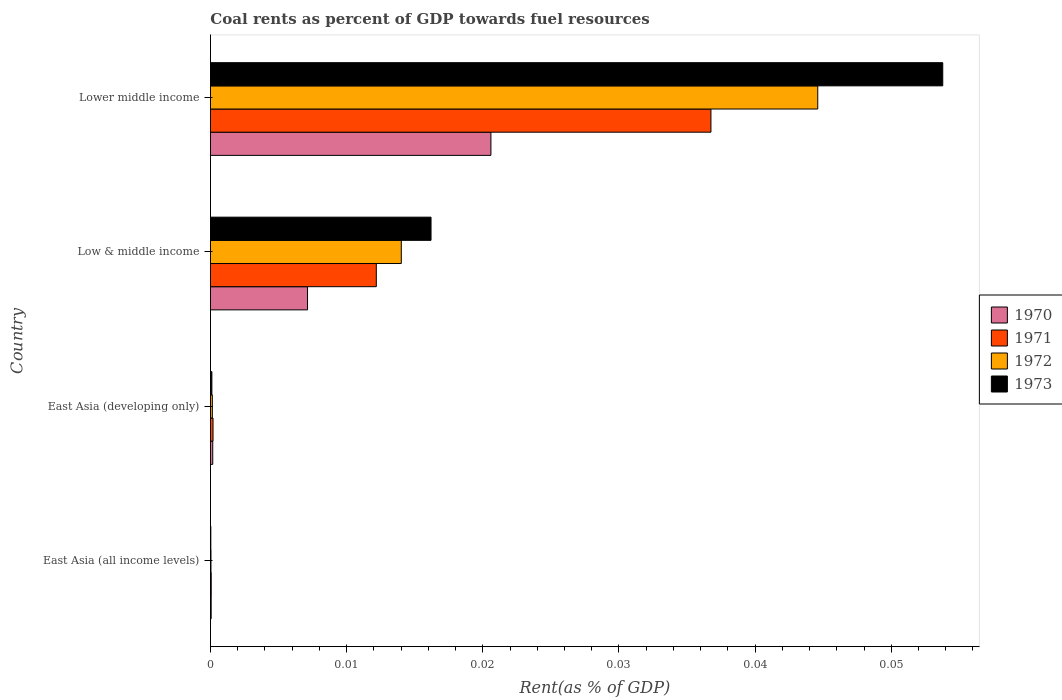How many different coloured bars are there?
Your response must be concise. 4. How many groups of bars are there?
Keep it short and to the point. 4. Are the number of bars on each tick of the Y-axis equal?
Offer a terse response. Yes. How many bars are there on the 3rd tick from the bottom?
Ensure brevity in your answer.  4. What is the label of the 2nd group of bars from the top?
Offer a very short reply. Low & middle income. What is the coal rent in 1972 in East Asia (all income levels)?
Provide a succinct answer. 3.67730514806032e-5. Across all countries, what is the maximum coal rent in 1970?
Provide a succinct answer. 0.02. Across all countries, what is the minimum coal rent in 1970?
Give a very brief answer. 5.1314079013758e-5. In which country was the coal rent in 1970 maximum?
Offer a very short reply. Lower middle income. In which country was the coal rent in 1970 minimum?
Provide a succinct answer. East Asia (all income levels). What is the total coal rent in 1973 in the graph?
Your response must be concise. 0.07. What is the difference between the coal rent in 1971 in East Asia (developing only) and that in Lower middle income?
Offer a terse response. -0.04. What is the difference between the coal rent in 1973 in Low & middle income and the coal rent in 1971 in East Asia (all income levels)?
Your answer should be very brief. 0.02. What is the average coal rent in 1970 per country?
Make the answer very short. 0.01. What is the difference between the coal rent in 1972 and coal rent in 1970 in East Asia (developing only)?
Provide a short and direct response. -2.9435221340923012e-5. What is the ratio of the coal rent in 1972 in East Asia (developing only) to that in Lower middle income?
Ensure brevity in your answer.  0. Is the coal rent in 1970 in East Asia (all income levels) less than that in East Asia (developing only)?
Ensure brevity in your answer.  Yes. Is the difference between the coal rent in 1972 in Low & middle income and Lower middle income greater than the difference between the coal rent in 1970 in Low & middle income and Lower middle income?
Your answer should be very brief. No. What is the difference between the highest and the second highest coal rent in 1972?
Your response must be concise. 0.03. What is the difference between the highest and the lowest coal rent in 1973?
Keep it short and to the point. 0.05. How many bars are there?
Provide a succinct answer. 16. Are all the bars in the graph horizontal?
Your response must be concise. Yes. Are the values on the major ticks of X-axis written in scientific E-notation?
Ensure brevity in your answer.  No. Does the graph contain any zero values?
Your answer should be compact. No. Does the graph contain grids?
Ensure brevity in your answer.  No. How many legend labels are there?
Ensure brevity in your answer.  4. How are the legend labels stacked?
Provide a succinct answer. Vertical. What is the title of the graph?
Give a very brief answer. Coal rents as percent of GDP towards fuel resources. What is the label or title of the X-axis?
Offer a very short reply. Rent(as % of GDP). What is the Rent(as % of GDP) of 1970 in East Asia (all income levels)?
Your answer should be compact. 5.1314079013758e-5. What is the Rent(as % of GDP) in 1971 in East Asia (all income levels)?
Provide a succinct answer. 5.470114168356261e-5. What is the Rent(as % of GDP) in 1972 in East Asia (all income levels)?
Your answer should be very brief. 3.67730514806032e-5. What is the Rent(as % of GDP) of 1973 in East Asia (all income levels)?
Your answer should be compact. 2.64171247686014e-5. What is the Rent(as % of GDP) in 1970 in East Asia (developing only)?
Give a very brief answer. 0. What is the Rent(as % of GDP) in 1971 in East Asia (developing only)?
Your answer should be very brief. 0. What is the Rent(as % of GDP) in 1972 in East Asia (developing only)?
Keep it short and to the point. 0. What is the Rent(as % of GDP) of 1973 in East Asia (developing only)?
Provide a succinct answer. 0. What is the Rent(as % of GDP) of 1970 in Low & middle income?
Your answer should be compact. 0.01. What is the Rent(as % of GDP) of 1971 in Low & middle income?
Your response must be concise. 0.01. What is the Rent(as % of GDP) in 1972 in Low & middle income?
Provide a short and direct response. 0.01. What is the Rent(as % of GDP) of 1973 in Low & middle income?
Offer a very short reply. 0.02. What is the Rent(as % of GDP) of 1970 in Lower middle income?
Offer a very short reply. 0.02. What is the Rent(as % of GDP) of 1971 in Lower middle income?
Ensure brevity in your answer.  0.04. What is the Rent(as % of GDP) of 1972 in Lower middle income?
Provide a succinct answer. 0.04. What is the Rent(as % of GDP) of 1973 in Lower middle income?
Your response must be concise. 0.05. Across all countries, what is the maximum Rent(as % of GDP) of 1970?
Keep it short and to the point. 0.02. Across all countries, what is the maximum Rent(as % of GDP) in 1971?
Offer a terse response. 0.04. Across all countries, what is the maximum Rent(as % of GDP) in 1972?
Offer a very short reply. 0.04. Across all countries, what is the maximum Rent(as % of GDP) in 1973?
Make the answer very short. 0.05. Across all countries, what is the minimum Rent(as % of GDP) in 1970?
Your response must be concise. 5.1314079013758e-5. Across all countries, what is the minimum Rent(as % of GDP) in 1971?
Make the answer very short. 5.470114168356261e-5. Across all countries, what is the minimum Rent(as % of GDP) of 1972?
Provide a short and direct response. 3.67730514806032e-5. Across all countries, what is the minimum Rent(as % of GDP) in 1973?
Your answer should be compact. 2.64171247686014e-5. What is the total Rent(as % of GDP) in 1970 in the graph?
Your answer should be compact. 0.03. What is the total Rent(as % of GDP) of 1971 in the graph?
Make the answer very short. 0.05. What is the total Rent(as % of GDP) of 1972 in the graph?
Offer a terse response. 0.06. What is the total Rent(as % of GDP) of 1973 in the graph?
Offer a very short reply. 0.07. What is the difference between the Rent(as % of GDP) of 1970 in East Asia (all income levels) and that in East Asia (developing only)?
Your answer should be compact. -0. What is the difference between the Rent(as % of GDP) in 1971 in East Asia (all income levels) and that in East Asia (developing only)?
Provide a succinct answer. -0. What is the difference between the Rent(as % of GDP) of 1972 in East Asia (all income levels) and that in East Asia (developing only)?
Make the answer very short. -0. What is the difference between the Rent(as % of GDP) of 1973 in East Asia (all income levels) and that in East Asia (developing only)?
Provide a short and direct response. -0. What is the difference between the Rent(as % of GDP) of 1970 in East Asia (all income levels) and that in Low & middle income?
Offer a very short reply. -0.01. What is the difference between the Rent(as % of GDP) in 1971 in East Asia (all income levels) and that in Low & middle income?
Your answer should be very brief. -0.01. What is the difference between the Rent(as % of GDP) in 1972 in East Asia (all income levels) and that in Low & middle income?
Keep it short and to the point. -0.01. What is the difference between the Rent(as % of GDP) of 1973 in East Asia (all income levels) and that in Low & middle income?
Your answer should be compact. -0.02. What is the difference between the Rent(as % of GDP) in 1970 in East Asia (all income levels) and that in Lower middle income?
Offer a very short reply. -0.02. What is the difference between the Rent(as % of GDP) of 1971 in East Asia (all income levels) and that in Lower middle income?
Keep it short and to the point. -0.04. What is the difference between the Rent(as % of GDP) of 1972 in East Asia (all income levels) and that in Lower middle income?
Provide a succinct answer. -0.04. What is the difference between the Rent(as % of GDP) in 1973 in East Asia (all income levels) and that in Lower middle income?
Make the answer very short. -0.05. What is the difference between the Rent(as % of GDP) in 1970 in East Asia (developing only) and that in Low & middle income?
Ensure brevity in your answer.  -0.01. What is the difference between the Rent(as % of GDP) of 1971 in East Asia (developing only) and that in Low & middle income?
Your answer should be compact. -0.01. What is the difference between the Rent(as % of GDP) of 1972 in East Asia (developing only) and that in Low & middle income?
Make the answer very short. -0.01. What is the difference between the Rent(as % of GDP) in 1973 in East Asia (developing only) and that in Low & middle income?
Provide a succinct answer. -0.02. What is the difference between the Rent(as % of GDP) in 1970 in East Asia (developing only) and that in Lower middle income?
Ensure brevity in your answer.  -0.02. What is the difference between the Rent(as % of GDP) of 1971 in East Asia (developing only) and that in Lower middle income?
Offer a very short reply. -0.04. What is the difference between the Rent(as % of GDP) of 1972 in East Asia (developing only) and that in Lower middle income?
Offer a very short reply. -0.04. What is the difference between the Rent(as % of GDP) in 1973 in East Asia (developing only) and that in Lower middle income?
Your answer should be very brief. -0.05. What is the difference between the Rent(as % of GDP) in 1970 in Low & middle income and that in Lower middle income?
Your answer should be compact. -0.01. What is the difference between the Rent(as % of GDP) in 1971 in Low & middle income and that in Lower middle income?
Provide a succinct answer. -0.02. What is the difference between the Rent(as % of GDP) of 1972 in Low & middle income and that in Lower middle income?
Your response must be concise. -0.03. What is the difference between the Rent(as % of GDP) of 1973 in Low & middle income and that in Lower middle income?
Offer a terse response. -0.04. What is the difference between the Rent(as % of GDP) in 1970 in East Asia (all income levels) and the Rent(as % of GDP) in 1971 in East Asia (developing only)?
Offer a very short reply. -0. What is the difference between the Rent(as % of GDP) in 1970 in East Asia (all income levels) and the Rent(as % of GDP) in 1972 in East Asia (developing only)?
Ensure brevity in your answer.  -0. What is the difference between the Rent(as % of GDP) in 1970 in East Asia (all income levels) and the Rent(as % of GDP) in 1973 in East Asia (developing only)?
Ensure brevity in your answer.  -0. What is the difference between the Rent(as % of GDP) in 1971 in East Asia (all income levels) and the Rent(as % of GDP) in 1972 in East Asia (developing only)?
Offer a terse response. -0. What is the difference between the Rent(as % of GDP) of 1972 in East Asia (all income levels) and the Rent(as % of GDP) of 1973 in East Asia (developing only)?
Offer a very short reply. -0. What is the difference between the Rent(as % of GDP) of 1970 in East Asia (all income levels) and the Rent(as % of GDP) of 1971 in Low & middle income?
Your response must be concise. -0.01. What is the difference between the Rent(as % of GDP) in 1970 in East Asia (all income levels) and the Rent(as % of GDP) in 1972 in Low & middle income?
Give a very brief answer. -0.01. What is the difference between the Rent(as % of GDP) in 1970 in East Asia (all income levels) and the Rent(as % of GDP) in 1973 in Low & middle income?
Make the answer very short. -0.02. What is the difference between the Rent(as % of GDP) of 1971 in East Asia (all income levels) and the Rent(as % of GDP) of 1972 in Low & middle income?
Your answer should be very brief. -0.01. What is the difference between the Rent(as % of GDP) in 1971 in East Asia (all income levels) and the Rent(as % of GDP) in 1973 in Low & middle income?
Offer a very short reply. -0.02. What is the difference between the Rent(as % of GDP) in 1972 in East Asia (all income levels) and the Rent(as % of GDP) in 1973 in Low & middle income?
Give a very brief answer. -0.02. What is the difference between the Rent(as % of GDP) of 1970 in East Asia (all income levels) and the Rent(as % of GDP) of 1971 in Lower middle income?
Make the answer very short. -0.04. What is the difference between the Rent(as % of GDP) of 1970 in East Asia (all income levels) and the Rent(as % of GDP) of 1972 in Lower middle income?
Your answer should be very brief. -0.04. What is the difference between the Rent(as % of GDP) in 1970 in East Asia (all income levels) and the Rent(as % of GDP) in 1973 in Lower middle income?
Your answer should be very brief. -0.05. What is the difference between the Rent(as % of GDP) in 1971 in East Asia (all income levels) and the Rent(as % of GDP) in 1972 in Lower middle income?
Give a very brief answer. -0.04. What is the difference between the Rent(as % of GDP) of 1971 in East Asia (all income levels) and the Rent(as % of GDP) of 1973 in Lower middle income?
Offer a very short reply. -0.05. What is the difference between the Rent(as % of GDP) of 1972 in East Asia (all income levels) and the Rent(as % of GDP) of 1973 in Lower middle income?
Your response must be concise. -0.05. What is the difference between the Rent(as % of GDP) in 1970 in East Asia (developing only) and the Rent(as % of GDP) in 1971 in Low & middle income?
Make the answer very short. -0.01. What is the difference between the Rent(as % of GDP) in 1970 in East Asia (developing only) and the Rent(as % of GDP) in 1972 in Low & middle income?
Provide a short and direct response. -0.01. What is the difference between the Rent(as % of GDP) of 1970 in East Asia (developing only) and the Rent(as % of GDP) of 1973 in Low & middle income?
Your response must be concise. -0.02. What is the difference between the Rent(as % of GDP) in 1971 in East Asia (developing only) and the Rent(as % of GDP) in 1972 in Low & middle income?
Offer a very short reply. -0.01. What is the difference between the Rent(as % of GDP) in 1971 in East Asia (developing only) and the Rent(as % of GDP) in 1973 in Low & middle income?
Ensure brevity in your answer.  -0.02. What is the difference between the Rent(as % of GDP) in 1972 in East Asia (developing only) and the Rent(as % of GDP) in 1973 in Low & middle income?
Keep it short and to the point. -0.02. What is the difference between the Rent(as % of GDP) in 1970 in East Asia (developing only) and the Rent(as % of GDP) in 1971 in Lower middle income?
Offer a very short reply. -0.04. What is the difference between the Rent(as % of GDP) in 1970 in East Asia (developing only) and the Rent(as % of GDP) in 1972 in Lower middle income?
Offer a terse response. -0.04. What is the difference between the Rent(as % of GDP) in 1970 in East Asia (developing only) and the Rent(as % of GDP) in 1973 in Lower middle income?
Your response must be concise. -0.05. What is the difference between the Rent(as % of GDP) of 1971 in East Asia (developing only) and the Rent(as % of GDP) of 1972 in Lower middle income?
Your answer should be compact. -0.04. What is the difference between the Rent(as % of GDP) of 1971 in East Asia (developing only) and the Rent(as % of GDP) of 1973 in Lower middle income?
Ensure brevity in your answer.  -0.05. What is the difference between the Rent(as % of GDP) in 1972 in East Asia (developing only) and the Rent(as % of GDP) in 1973 in Lower middle income?
Your response must be concise. -0.05. What is the difference between the Rent(as % of GDP) in 1970 in Low & middle income and the Rent(as % of GDP) in 1971 in Lower middle income?
Give a very brief answer. -0.03. What is the difference between the Rent(as % of GDP) of 1970 in Low & middle income and the Rent(as % of GDP) of 1972 in Lower middle income?
Provide a short and direct response. -0.04. What is the difference between the Rent(as % of GDP) of 1970 in Low & middle income and the Rent(as % of GDP) of 1973 in Lower middle income?
Provide a short and direct response. -0.05. What is the difference between the Rent(as % of GDP) in 1971 in Low & middle income and the Rent(as % of GDP) in 1972 in Lower middle income?
Ensure brevity in your answer.  -0.03. What is the difference between the Rent(as % of GDP) of 1971 in Low & middle income and the Rent(as % of GDP) of 1973 in Lower middle income?
Give a very brief answer. -0.04. What is the difference between the Rent(as % of GDP) of 1972 in Low & middle income and the Rent(as % of GDP) of 1973 in Lower middle income?
Offer a terse response. -0.04. What is the average Rent(as % of GDP) of 1970 per country?
Provide a short and direct response. 0.01. What is the average Rent(as % of GDP) of 1971 per country?
Provide a short and direct response. 0.01. What is the average Rent(as % of GDP) of 1972 per country?
Your answer should be very brief. 0.01. What is the average Rent(as % of GDP) in 1973 per country?
Your answer should be compact. 0.02. What is the difference between the Rent(as % of GDP) in 1970 and Rent(as % of GDP) in 1971 in East Asia (all income levels)?
Give a very brief answer. -0. What is the difference between the Rent(as % of GDP) in 1970 and Rent(as % of GDP) in 1973 in East Asia (all income levels)?
Provide a short and direct response. 0. What is the difference between the Rent(as % of GDP) of 1972 and Rent(as % of GDP) of 1973 in East Asia (all income levels)?
Your answer should be compact. 0. What is the difference between the Rent(as % of GDP) in 1970 and Rent(as % of GDP) in 1971 in East Asia (developing only)?
Provide a short and direct response. -0. What is the difference between the Rent(as % of GDP) of 1970 and Rent(as % of GDP) of 1971 in Low & middle income?
Provide a short and direct response. -0.01. What is the difference between the Rent(as % of GDP) of 1970 and Rent(as % of GDP) of 1972 in Low & middle income?
Your answer should be very brief. -0.01. What is the difference between the Rent(as % of GDP) in 1970 and Rent(as % of GDP) in 1973 in Low & middle income?
Give a very brief answer. -0.01. What is the difference between the Rent(as % of GDP) in 1971 and Rent(as % of GDP) in 1972 in Low & middle income?
Provide a short and direct response. -0. What is the difference between the Rent(as % of GDP) of 1971 and Rent(as % of GDP) of 1973 in Low & middle income?
Make the answer very short. -0. What is the difference between the Rent(as % of GDP) in 1972 and Rent(as % of GDP) in 1973 in Low & middle income?
Your response must be concise. -0. What is the difference between the Rent(as % of GDP) of 1970 and Rent(as % of GDP) of 1971 in Lower middle income?
Make the answer very short. -0.02. What is the difference between the Rent(as % of GDP) in 1970 and Rent(as % of GDP) in 1972 in Lower middle income?
Your answer should be very brief. -0.02. What is the difference between the Rent(as % of GDP) in 1970 and Rent(as % of GDP) in 1973 in Lower middle income?
Your answer should be very brief. -0.03. What is the difference between the Rent(as % of GDP) of 1971 and Rent(as % of GDP) of 1972 in Lower middle income?
Offer a very short reply. -0.01. What is the difference between the Rent(as % of GDP) of 1971 and Rent(as % of GDP) of 1973 in Lower middle income?
Provide a succinct answer. -0.02. What is the difference between the Rent(as % of GDP) in 1972 and Rent(as % of GDP) in 1973 in Lower middle income?
Ensure brevity in your answer.  -0.01. What is the ratio of the Rent(as % of GDP) of 1970 in East Asia (all income levels) to that in East Asia (developing only)?
Your response must be concise. 0.31. What is the ratio of the Rent(as % of GDP) of 1971 in East Asia (all income levels) to that in East Asia (developing only)?
Give a very brief answer. 0.29. What is the ratio of the Rent(as % of GDP) in 1972 in East Asia (all income levels) to that in East Asia (developing only)?
Ensure brevity in your answer.  0.27. What is the ratio of the Rent(as % of GDP) in 1973 in East Asia (all income levels) to that in East Asia (developing only)?
Provide a succinct answer. 0.26. What is the ratio of the Rent(as % of GDP) in 1970 in East Asia (all income levels) to that in Low & middle income?
Give a very brief answer. 0.01. What is the ratio of the Rent(as % of GDP) in 1971 in East Asia (all income levels) to that in Low & middle income?
Your answer should be very brief. 0. What is the ratio of the Rent(as % of GDP) in 1972 in East Asia (all income levels) to that in Low & middle income?
Keep it short and to the point. 0. What is the ratio of the Rent(as % of GDP) in 1973 in East Asia (all income levels) to that in Low & middle income?
Provide a succinct answer. 0. What is the ratio of the Rent(as % of GDP) of 1970 in East Asia (all income levels) to that in Lower middle income?
Provide a succinct answer. 0. What is the ratio of the Rent(as % of GDP) in 1971 in East Asia (all income levels) to that in Lower middle income?
Offer a very short reply. 0. What is the ratio of the Rent(as % of GDP) of 1972 in East Asia (all income levels) to that in Lower middle income?
Keep it short and to the point. 0. What is the ratio of the Rent(as % of GDP) in 1970 in East Asia (developing only) to that in Low & middle income?
Your answer should be compact. 0.02. What is the ratio of the Rent(as % of GDP) of 1971 in East Asia (developing only) to that in Low & middle income?
Give a very brief answer. 0.02. What is the ratio of the Rent(as % of GDP) in 1972 in East Asia (developing only) to that in Low & middle income?
Offer a terse response. 0.01. What is the ratio of the Rent(as % of GDP) of 1973 in East Asia (developing only) to that in Low & middle income?
Ensure brevity in your answer.  0.01. What is the ratio of the Rent(as % of GDP) in 1970 in East Asia (developing only) to that in Lower middle income?
Keep it short and to the point. 0.01. What is the ratio of the Rent(as % of GDP) of 1971 in East Asia (developing only) to that in Lower middle income?
Ensure brevity in your answer.  0.01. What is the ratio of the Rent(as % of GDP) in 1972 in East Asia (developing only) to that in Lower middle income?
Offer a very short reply. 0. What is the ratio of the Rent(as % of GDP) of 1973 in East Asia (developing only) to that in Lower middle income?
Offer a terse response. 0. What is the ratio of the Rent(as % of GDP) in 1970 in Low & middle income to that in Lower middle income?
Keep it short and to the point. 0.35. What is the ratio of the Rent(as % of GDP) in 1971 in Low & middle income to that in Lower middle income?
Your answer should be compact. 0.33. What is the ratio of the Rent(as % of GDP) in 1972 in Low & middle income to that in Lower middle income?
Provide a succinct answer. 0.31. What is the ratio of the Rent(as % of GDP) of 1973 in Low & middle income to that in Lower middle income?
Keep it short and to the point. 0.3. What is the difference between the highest and the second highest Rent(as % of GDP) in 1970?
Offer a very short reply. 0.01. What is the difference between the highest and the second highest Rent(as % of GDP) in 1971?
Provide a short and direct response. 0.02. What is the difference between the highest and the second highest Rent(as % of GDP) in 1972?
Your answer should be very brief. 0.03. What is the difference between the highest and the second highest Rent(as % of GDP) of 1973?
Offer a very short reply. 0.04. What is the difference between the highest and the lowest Rent(as % of GDP) in 1970?
Your answer should be very brief. 0.02. What is the difference between the highest and the lowest Rent(as % of GDP) in 1971?
Provide a short and direct response. 0.04. What is the difference between the highest and the lowest Rent(as % of GDP) in 1972?
Offer a very short reply. 0.04. What is the difference between the highest and the lowest Rent(as % of GDP) in 1973?
Provide a short and direct response. 0.05. 